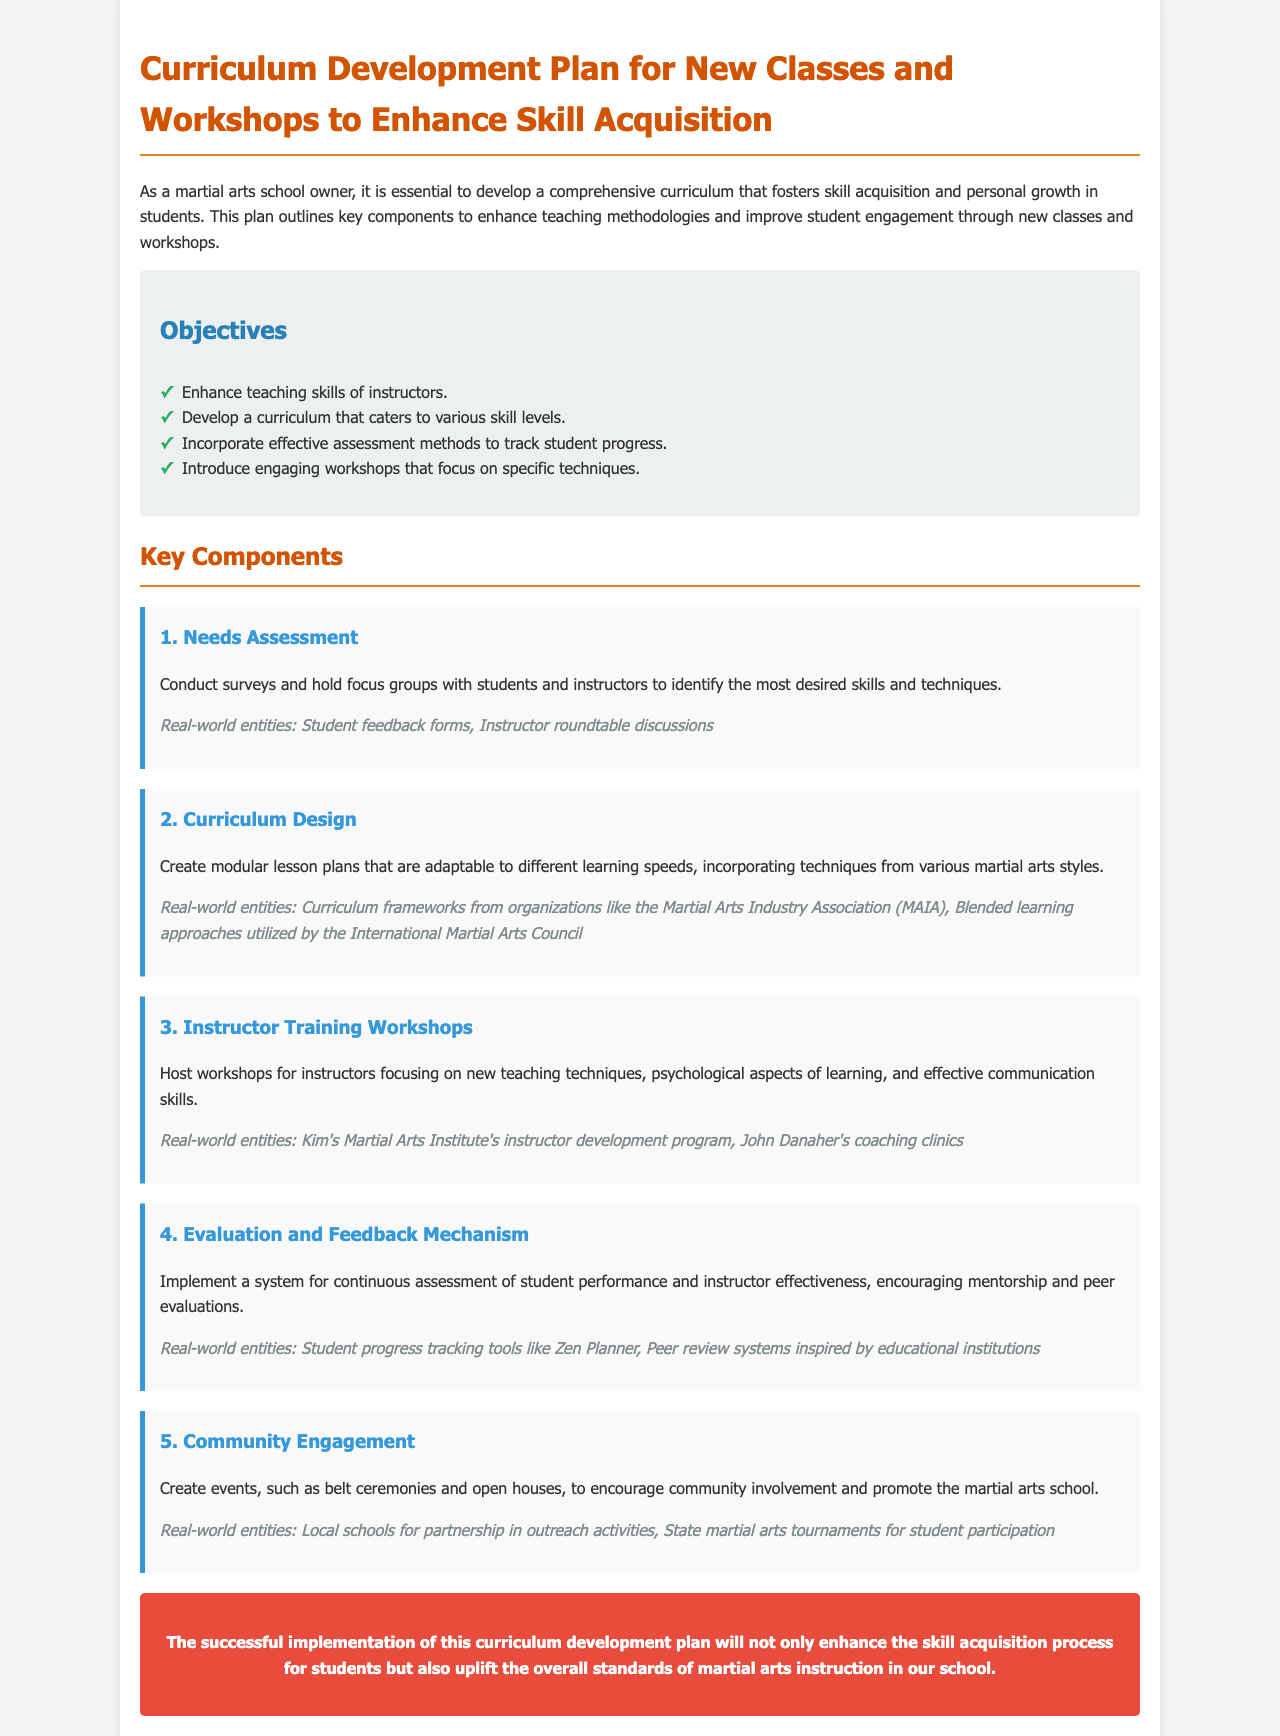What is the title of the document? The title is mentioned in the header of the document.
Answer: Curriculum Development Plan for New Classes and Workshops to Enhance Skill Acquisition How many key components are outlined in the document? The document lists five key components under the "Key Components" section.
Answer: 5 What is the first objective listed in the document? The objectives are enumerated in a list under the "Objectives" section.
Answer: Enhance teaching skills of instructors What learning aspects are focused on in the instructor training workshops? The workshops emphasize aspects related to new teaching techniques and related skills.
Answer: New teaching techniques, psychological aspects of learning, and effective communication skills Which organization is mentioned as a source for curriculum frameworks? This organization is referenced in the context of curriculum design.
Answer: Martial Arts Industry Association (MAIA) What is the intended outcome of the curriculum development plan? The outcome is described in the conclusion section of the document.
Answer: Enhance the skill acquisition process for students Which method is suggested for community engagement in the document? The document suggests creating events as a way to engage with the community.
Answer: Events like belt ceremonies and open houses What is recommended to implement for student progress tracking? The document specifies a system for assessing student performance and instructor effectiveness.
Answer: Student progress tracking tools like Zen Planner In which section is the Needs Assessment discussed? The Needs Assessment is one of the numbered components in the "Key Components" section.
Answer: Key Components 